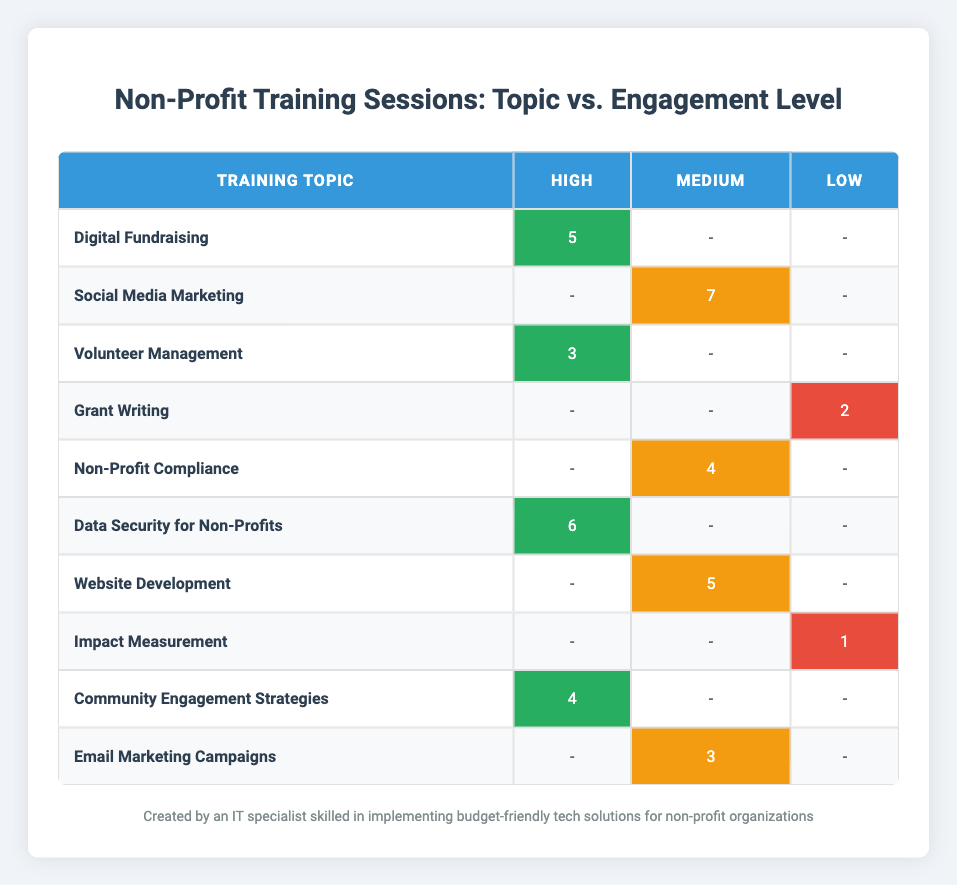What is the number of training sessions for "Digital Fundraising"? In the table, look for the row where the "Training Topic" is "Digital Fundraising". The corresponding "Number of Sessions" column shows the value 5.
Answer: 5 How many training sessions had a "High" participant engagement level? To find this, locate all rows where "Participant Engagement Level" is marked as "High". The values in the "Number of Sessions" column for these rows are 5, 3, 6, and 4. Adding them together gives 5 + 3 + 6 + 4 = 18.
Answer: 18 Is there any training topic with a "Low" engagement level that had more than 2 sessions? Reviewing the table, the only training topic with a "Low" engagement level is "Grant Writing" (2 sessions) and "Impact Measurement" (1 session). Both values are 2 or less, so the answer is no.
Answer: No Which training topic had the highest number of sessions and what was the engagement level? Upon reviewing the "Number of Sessions" column, the highest value is 7 found under "Social Media Marketing", which has a "Medium" engagement level.
Answer: Social Media Marketing, Medium What is the difference in training sessions between "Data Security for Non-Profits" and "Non-Profit Compliance"? The "Number of Sessions" for "Data Security for Non-Profits" is 6 and for "Non-Profit Compliance" it is 4. The difference is calculated as 6 - 4 = 2.
Answer: 2 How many training sessions are conducted with "Medium" engagement level? Identifying the rows with "Medium" in the "Participant Engagement Level", the values are 7, 4, 5, and 3. Adding these up results in 7 + 4 + 5 + 3 = 19.
Answer: 19 Are there more training sessions with "High" engagement or "Medium" engagement? Sum the sessions for both engagement levels: "High" sessions total 18 and "Medium" sessions total 19. Since 19 > 18, therefore, there are more sessions with "Medium" engagement.
Answer: Medium engagement Which training topic had a "High" engagement and the fewest number of sessions? Assessing the "High" engagement topics: "Digital Fundraising" (5), "Volunteer Management" (3), "Data Security for Non-Profits" (6), and "Community Engagement Strategies" (4). The least is "Volunteer Management" with 3 sessions.
Answer: Volunteer Management, 3 